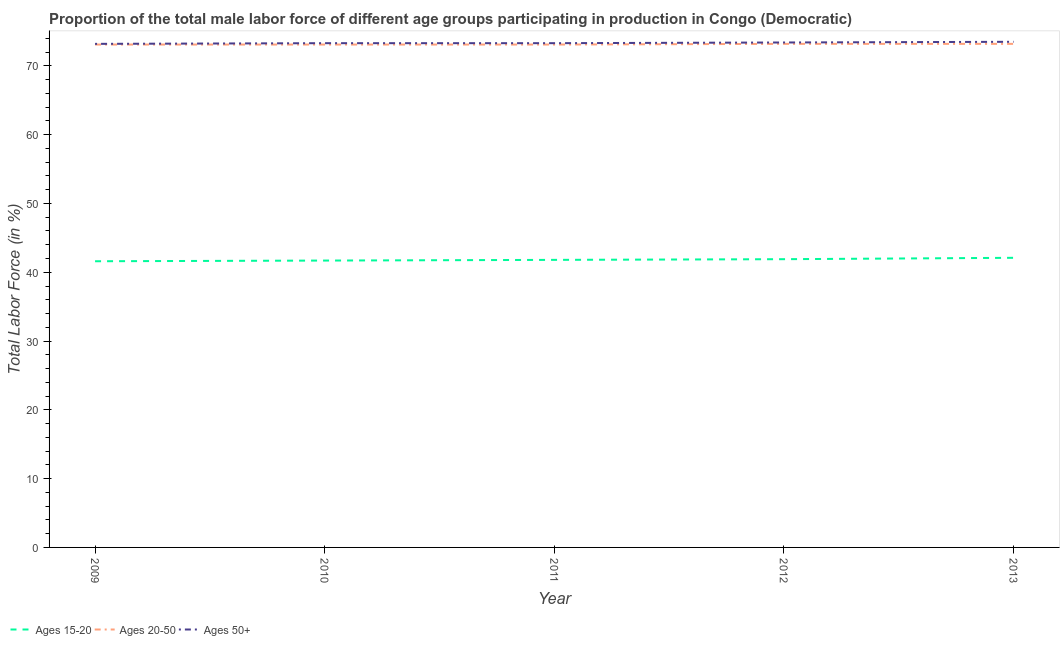How many different coloured lines are there?
Give a very brief answer. 3. What is the percentage of male labor force within the age group 15-20 in 2010?
Provide a short and direct response. 41.7. Across all years, what is the maximum percentage of male labor force within the age group 15-20?
Keep it short and to the point. 42.1. Across all years, what is the minimum percentage of male labor force within the age group 20-50?
Provide a short and direct response. 73.1. In which year was the percentage of male labor force within the age group 20-50 maximum?
Offer a very short reply. 2012. What is the total percentage of male labor force within the age group 20-50 in the graph?
Provide a succinct answer. 365.7. What is the difference between the percentage of male labor force above age 50 in 2010 and that in 2013?
Offer a very short reply. -0.2. What is the difference between the percentage of male labor force within the age group 20-50 in 2012 and the percentage of male labor force within the age group 15-20 in 2009?
Provide a succinct answer. 31.6. What is the average percentage of male labor force above age 50 per year?
Your answer should be very brief. 73.34. In the year 2013, what is the difference between the percentage of male labor force within the age group 20-50 and percentage of male labor force within the age group 15-20?
Offer a very short reply. 31.1. In how many years, is the percentage of male labor force within the age group 15-20 greater than 36 %?
Make the answer very short. 5. What is the ratio of the percentage of male labor force within the age group 20-50 in 2011 to that in 2013?
Ensure brevity in your answer.  1. What is the difference between the highest and the second highest percentage of male labor force above age 50?
Give a very brief answer. 0.1. Is the sum of the percentage of male labor force within the age group 20-50 in 2012 and 2013 greater than the maximum percentage of male labor force within the age group 15-20 across all years?
Provide a short and direct response. Yes. Is it the case that in every year, the sum of the percentage of male labor force within the age group 15-20 and percentage of male labor force within the age group 20-50 is greater than the percentage of male labor force above age 50?
Your answer should be compact. Yes. Is the percentage of male labor force within the age group 15-20 strictly less than the percentage of male labor force above age 50 over the years?
Offer a very short reply. Yes. What is the difference between two consecutive major ticks on the Y-axis?
Provide a short and direct response. 10. Does the graph contain any zero values?
Give a very brief answer. No. Does the graph contain grids?
Ensure brevity in your answer.  No. Where does the legend appear in the graph?
Ensure brevity in your answer.  Bottom left. What is the title of the graph?
Provide a succinct answer. Proportion of the total male labor force of different age groups participating in production in Congo (Democratic). Does "Taxes" appear as one of the legend labels in the graph?
Provide a succinct answer. No. What is the label or title of the X-axis?
Provide a succinct answer. Year. What is the label or title of the Y-axis?
Make the answer very short. Total Labor Force (in %). What is the Total Labor Force (in %) in Ages 15-20 in 2009?
Your answer should be very brief. 41.6. What is the Total Labor Force (in %) of Ages 20-50 in 2009?
Your answer should be very brief. 73.1. What is the Total Labor Force (in %) in Ages 50+ in 2009?
Your answer should be very brief. 73.2. What is the Total Labor Force (in %) of Ages 15-20 in 2010?
Offer a very short reply. 41.7. What is the Total Labor Force (in %) in Ages 20-50 in 2010?
Give a very brief answer. 73.1. What is the Total Labor Force (in %) in Ages 50+ in 2010?
Provide a succinct answer. 73.3. What is the Total Labor Force (in %) in Ages 15-20 in 2011?
Ensure brevity in your answer.  41.8. What is the Total Labor Force (in %) of Ages 20-50 in 2011?
Give a very brief answer. 73.1. What is the Total Labor Force (in %) in Ages 50+ in 2011?
Provide a short and direct response. 73.3. What is the Total Labor Force (in %) of Ages 15-20 in 2012?
Ensure brevity in your answer.  41.9. What is the Total Labor Force (in %) of Ages 20-50 in 2012?
Make the answer very short. 73.2. What is the Total Labor Force (in %) in Ages 50+ in 2012?
Provide a succinct answer. 73.4. What is the Total Labor Force (in %) of Ages 15-20 in 2013?
Your answer should be compact. 42.1. What is the Total Labor Force (in %) in Ages 20-50 in 2013?
Ensure brevity in your answer.  73.2. What is the Total Labor Force (in %) in Ages 50+ in 2013?
Your answer should be very brief. 73.5. Across all years, what is the maximum Total Labor Force (in %) in Ages 15-20?
Your answer should be very brief. 42.1. Across all years, what is the maximum Total Labor Force (in %) in Ages 20-50?
Ensure brevity in your answer.  73.2. Across all years, what is the maximum Total Labor Force (in %) in Ages 50+?
Make the answer very short. 73.5. Across all years, what is the minimum Total Labor Force (in %) in Ages 15-20?
Your response must be concise. 41.6. Across all years, what is the minimum Total Labor Force (in %) of Ages 20-50?
Ensure brevity in your answer.  73.1. Across all years, what is the minimum Total Labor Force (in %) of Ages 50+?
Ensure brevity in your answer.  73.2. What is the total Total Labor Force (in %) of Ages 15-20 in the graph?
Offer a very short reply. 209.1. What is the total Total Labor Force (in %) of Ages 20-50 in the graph?
Your answer should be compact. 365.7. What is the total Total Labor Force (in %) of Ages 50+ in the graph?
Your answer should be very brief. 366.7. What is the difference between the Total Labor Force (in %) in Ages 15-20 in 2009 and that in 2010?
Make the answer very short. -0.1. What is the difference between the Total Labor Force (in %) in Ages 50+ in 2009 and that in 2010?
Offer a terse response. -0.1. What is the difference between the Total Labor Force (in %) of Ages 15-20 in 2009 and that in 2011?
Ensure brevity in your answer.  -0.2. What is the difference between the Total Labor Force (in %) of Ages 20-50 in 2009 and that in 2011?
Ensure brevity in your answer.  0. What is the difference between the Total Labor Force (in %) in Ages 50+ in 2009 and that in 2011?
Offer a very short reply. -0.1. What is the difference between the Total Labor Force (in %) of Ages 15-20 in 2009 and that in 2012?
Provide a succinct answer. -0.3. What is the difference between the Total Labor Force (in %) in Ages 50+ in 2009 and that in 2012?
Make the answer very short. -0.2. What is the difference between the Total Labor Force (in %) in Ages 20-50 in 2009 and that in 2013?
Make the answer very short. -0.1. What is the difference between the Total Labor Force (in %) in Ages 20-50 in 2010 and that in 2011?
Your answer should be compact. 0. What is the difference between the Total Labor Force (in %) in Ages 50+ in 2010 and that in 2011?
Your answer should be compact. 0. What is the difference between the Total Labor Force (in %) of Ages 15-20 in 2010 and that in 2012?
Provide a short and direct response. -0.2. What is the difference between the Total Labor Force (in %) in Ages 20-50 in 2010 and that in 2012?
Offer a very short reply. -0.1. What is the difference between the Total Labor Force (in %) of Ages 50+ in 2010 and that in 2012?
Your answer should be compact. -0.1. What is the difference between the Total Labor Force (in %) in Ages 20-50 in 2010 and that in 2013?
Offer a very short reply. -0.1. What is the difference between the Total Labor Force (in %) of Ages 50+ in 2010 and that in 2013?
Provide a succinct answer. -0.2. What is the difference between the Total Labor Force (in %) in Ages 15-20 in 2011 and that in 2012?
Offer a terse response. -0.1. What is the difference between the Total Labor Force (in %) of Ages 20-50 in 2011 and that in 2012?
Make the answer very short. -0.1. What is the difference between the Total Labor Force (in %) in Ages 20-50 in 2011 and that in 2013?
Provide a succinct answer. -0.1. What is the difference between the Total Labor Force (in %) of Ages 50+ in 2011 and that in 2013?
Give a very brief answer. -0.2. What is the difference between the Total Labor Force (in %) in Ages 15-20 in 2012 and that in 2013?
Make the answer very short. -0.2. What is the difference between the Total Labor Force (in %) in Ages 15-20 in 2009 and the Total Labor Force (in %) in Ages 20-50 in 2010?
Give a very brief answer. -31.5. What is the difference between the Total Labor Force (in %) in Ages 15-20 in 2009 and the Total Labor Force (in %) in Ages 50+ in 2010?
Your answer should be very brief. -31.7. What is the difference between the Total Labor Force (in %) in Ages 15-20 in 2009 and the Total Labor Force (in %) in Ages 20-50 in 2011?
Your answer should be compact. -31.5. What is the difference between the Total Labor Force (in %) in Ages 15-20 in 2009 and the Total Labor Force (in %) in Ages 50+ in 2011?
Your answer should be compact. -31.7. What is the difference between the Total Labor Force (in %) in Ages 15-20 in 2009 and the Total Labor Force (in %) in Ages 20-50 in 2012?
Make the answer very short. -31.6. What is the difference between the Total Labor Force (in %) in Ages 15-20 in 2009 and the Total Labor Force (in %) in Ages 50+ in 2012?
Provide a succinct answer. -31.8. What is the difference between the Total Labor Force (in %) in Ages 15-20 in 2009 and the Total Labor Force (in %) in Ages 20-50 in 2013?
Offer a very short reply. -31.6. What is the difference between the Total Labor Force (in %) of Ages 15-20 in 2009 and the Total Labor Force (in %) of Ages 50+ in 2013?
Make the answer very short. -31.9. What is the difference between the Total Labor Force (in %) of Ages 20-50 in 2009 and the Total Labor Force (in %) of Ages 50+ in 2013?
Keep it short and to the point. -0.4. What is the difference between the Total Labor Force (in %) in Ages 15-20 in 2010 and the Total Labor Force (in %) in Ages 20-50 in 2011?
Make the answer very short. -31.4. What is the difference between the Total Labor Force (in %) of Ages 15-20 in 2010 and the Total Labor Force (in %) of Ages 50+ in 2011?
Keep it short and to the point. -31.6. What is the difference between the Total Labor Force (in %) in Ages 20-50 in 2010 and the Total Labor Force (in %) in Ages 50+ in 2011?
Provide a short and direct response. -0.2. What is the difference between the Total Labor Force (in %) of Ages 15-20 in 2010 and the Total Labor Force (in %) of Ages 20-50 in 2012?
Your answer should be compact. -31.5. What is the difference between the Total Labor Force (in %) in Ages 15-20 in 2010 and the Total Labor Force (in %) in Ages 50+ in 2012?
Give a very brief answer. -31.7. What is the difference between the Total Labor Force (in %) of Ages 20-50 in 2010 and the Total Labor Force (in %) of Ages 50+ in 2012?
Provide a short and direct response. -0.3. What is the difference between the Total Labor Force (in %) of Ages 15-20 in 2010 and the Total Labor Force (in %) of Ages 20-50 in 2013?
Ensure brevity in your answer.  -31.5. What is the difference between the Total Labor Force (in %) in Ages 15-20 in 2010 and the Total Labor Force (in %) in Ages 50+ in 2013?
Your answer should be compact. -31.8. What is the difference between the Total Labor Force (in %) in Ages 15-20 in 2011 and the Total Labor Force (in %) in Ages 20-50 in 2012?
Keep it short and to the point. -31.4. What is the difference between the Total Labor Force (in %) in Ages 15-20 in 2011 and the Total Labor Force (in %) in Ages 50+ in 2012?
Provide a short and direct response. -31.6. What is the difference between the Total Labor Force (in %) in Ages 20-50 in 2011 and the Total Labor Force (in %) in Ages 50+ in 2012?
Provide a succinct answer. -0.3. What is the difference between the Total Labor Force (in %) in Ages 15-20 in 2011 and the Total Labor Force (in %) in Ages 20-50 in 2013?
Keep it short and to the point. -31.4. What is the difference between the Total Labor Force (in %) in Ages 15-20 in 2011 and the Total Labor Force (in %) in Ages 50+ in 2013?
Provide a succinct answer. -31.7. What is the difference between the Total Labor Force (in %) of Ages 15-20 in 2012 and the Total Labor Force (in %) of Ages 20-50 in 2013?
Offer a very short reply. -31.3. What is the difference between the Total Labor Force (in %) in Ages 15-20 in 2012 and the Total Labor Force (in %) in Ages 50+ in 2013?
Offer a very short reply. -31.6. What is the difference between the Total Labor Force (in %) of Ages 20-50 in 2012 and the Total Labor Force (in %) of Ages 50+ in 2013?
Your answer should be compact. -0.3. What is the average Total Labor Force (in %) in Ages 15-20 per year?
Provide a succinct answer. 41.82. What is the average Total Labor Force (in %) of Ages 20-50 per year?
Keep it short and to the point. 73.14. What is the average Total Labor Force (in %) in Ages 50+ per year?
Keep it short and to the point. 73.34. In the year 2009, what is the difference between the Total Labor Force (in %) in Ages 15-20 and Total Labor Force (in %) in Ages 20-50?
Offer a very short reply. -31.5. In the year 2009, what is the difference between the Total Labor Force (in %) of Ages 15-20 and Total Labor Force (in %) of Ages 50+?
Ensure brevity in your answer.  -31.6. In the year 2010, what is the difference between the Total Labor Force (in %) in Ages 15-20 and Total Labor Force (in %) in Ages 20-50?
Offer a very short reply. -31.4. In the year 2010, what is the difference between the Total Labor Force (in %) of Ages 15-20 and Total Labor Force (in %) of Ages 50+?
Your response must be concise. -31.6. In the year 2010, what is the difference between the Total Labor Force (in %) in Ages 20-50 and Total Labor Force (in %) in Ages 50+?
Offer a terse response. -0.2. In the year 2011, what is the difference between the Total Labor Force (in %) in Ages 15-20 and Total Labor Force (in %) in Ages 20-50?
Ensure brevity in your answer.  -31.3. In the year 2011, what is the difference between the Total Labor Force (in %) in Ages 15-20 and Total Labor Force (in %) in Ages 50+?
Make the answer very short. -31.5. In the year 2012, what is the difference between the Total Labor Force (in %) of Ages 15-20 and Total Labor Force (in %) of Ages 20-50?
Your answer should be compact. -31.3. In the year 2012, what is the difference between the Total Labor Force (in %) of Ages 15-20 and Total Labor Force (in %) of Ages 50+?
Offer a terse response. -31.5. In the year 2013, what is the difference between the Total Labor Force (in %) of Ages 15-20 and Total Labor Force (in %) of Ages 20-50?
Provide a short and direct response. -31.1. In the year 2013, what is the difference between the Total Labor Force (in %) of Ages 15-20 and Total Labor Force (in %) of Ages 50+?
Make the answer very short. -31.4. In the year 2013, what is the difference between the Total Labor Force (in %) of Ages 20-50 and Total Labor Force (in %) of Ages 50+?
Your answer should be compact. -0.3. What is the ratio of the Total Labor Force (in %) in Ages 15-20 in 2009 to that in 2010?
Give a very brief answer. 1. What is the ratio of the Total Labor Force (in %) of Ages 50+ in 2009 to that in 2010?
Ensure brevity in your answer.  1. What is the ratio of the Total Labor Force (in %) of Ages 20-50 in 2009 to that in 2011?
Ensure brevity in your answer.  1. What is the ratio of the Total Labor Force (in %) of Ages 50+ in 2009 to that in 2011?
Your response must be concise. 1. What is the ratio of the Total Labor Force (in %) in Ages 20-50 in 2009 to that in 2012?
Your answer should be very brief. 1. What is the ratio of the Total Labor Force (in %) in Ages 50+ in 2009 to that in 2013?
Your answer should be very brief. 1. What is the ratio of the Total Labor Force (in %) of Ages 20-50 in 2010 to that in 2011?
Provide a short and direct response. 1. What is the ratio of the Total Labor Force (in %) in Ages 50+ in 2010 to that in 2011?
Your answer should be compact. 1. What is the ratio of the Total Labor Force (in %) of Ages 20-50 in 2010 to that in 2012?
Give a very brief answer. 1. What is the ratio of the Total Labor Force (in %) in Ages 50+ in 2010 to that in 2012?
Your answer should be very brief. 1. What is the ratio of the Total Labor Force (in %) of Ages 15-20 in 2010 to that in 2013?
Offer a very short reply. 0.99. What is the ratio of the Total Labor Force (in %) in Ages 20-50 in 2010 to that in 2013?
Offer a terse response. 1. What is the ratio of the Total Labor Force (in %) of Ages 20-50 in 2011 to that in 2013?
Provide a succinct answer. 1. What is the ratio of the Total Labor Force (in %) in Ages 15-20 in 2012 to that in 2013?
Ensure brevity in your answer.  1. What is the ratio of the Total Labor Force (in %) in Ages 50+ in 2012 to that in 2013?
Give a very brief answer. 1. What is the difference between the highest and the second highest Total Labor Force (in %) of Ages 50+?
Offer a terse response. 0.1. What is the difference between the highest and the lowest Total Labor Force (in %) of Ages 15-20?
Your answer should be compact. 0.5. What is the difference between the highest and the lowest Total Labor Force (in %) in Ages 50+?
Make the answer very short. 0.3. 